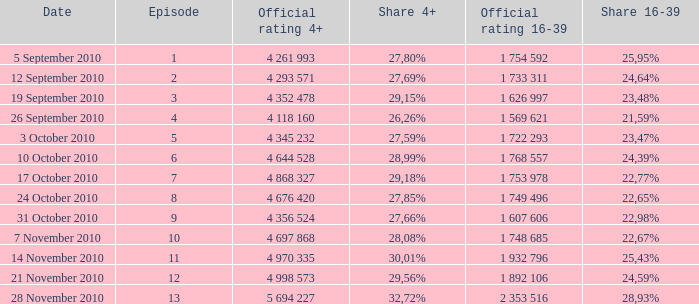What is the 16-39 share of the episode with a 4+ share of 30,01%? 25,43%. 